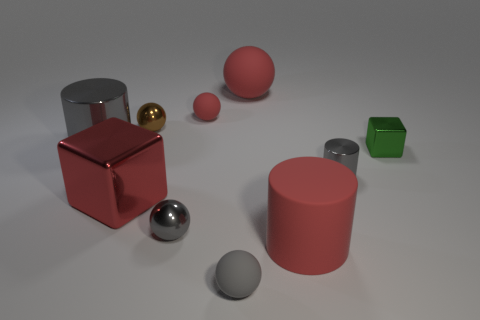Subtract 1 spheres. How many spheres are left? 4 Subtract all brown balls. How many balls are left? 4 Subtract all tiny gray rubber spheres. How many spheres are left? 4 Subtract all brown balls. Subtract all cyan cylinders. How many balls are left? 4 Subtract all cubes. How many objects are left? 8 Subtract all blue rubber blocks. Subtract all cylinders. How many objects are left? 7 Add 1 small red rubber spheres. How many small red rubber spheres are left? 2 Add 7 tiny gray cylinders. How many tiny gray cylinders exist? 8 Subtract 0 yellow blocks. How many objects are left? 10 